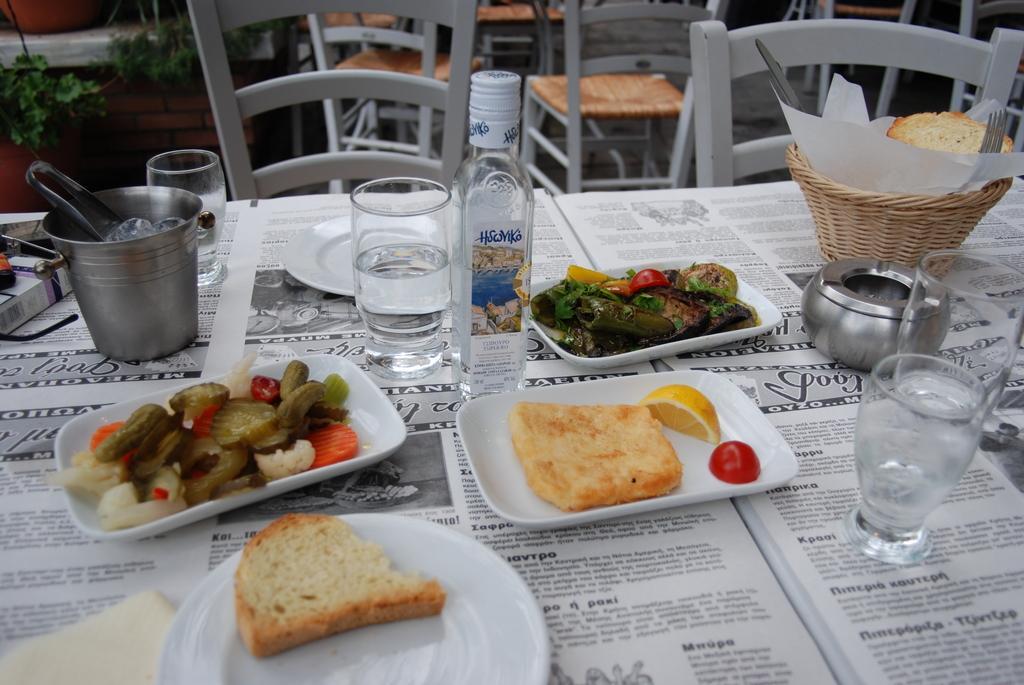Can you describe this image briefly? In this image we can see chairs and tables. There are many objects placed on the table. There are few plant pots at the left side of the image. 